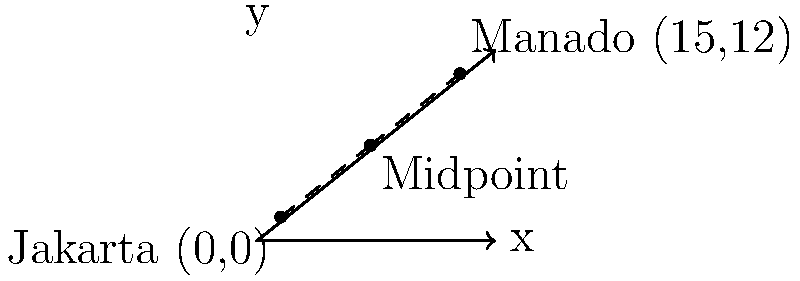Jakarta and Manado are two Indonesian cities known for their linguistic diversity. Jakarta, the capital, is located at coordinates (0,0), while Manado, known for its unique Manado Malay dialect, is at (15,12). Calculate the coordinates of the midpoint between these two linguistically rich cities. To find the midpoint between two points, we use the midpoint formula:

$$ \text{Midpoint} = (\frac{x_1 + x_2}{2}, \frac{y_1 + y_2}{2}) $$

Where $(x_1, y_1)$ are the coordinates of the first point and $(x_2, y_2)$ are the coordinates of the second point.

For Jakarta: $(x_1, y_1) = (0, 0)$
For Manado: $(x_2, y_2) = (15, 12)$

Step 1: Calculate the x-coordinate of the midpoint:
$$ x = \frac{x_1 + x_2}{2} = \frac{0 + 15}{2} = \frac{15}{2} = 7.5 $$

Step 2: Calculate the y-coordinate of the midpoint:
$$ y = \frac{y_1 + y_2}{2} = \frac{0 + 12}{2} = \frac{12}{2} = 6 $$

Therefore, the midpoint between Jakarta and Manado is (7.5, 6).
Answer: (7.5, 6) 